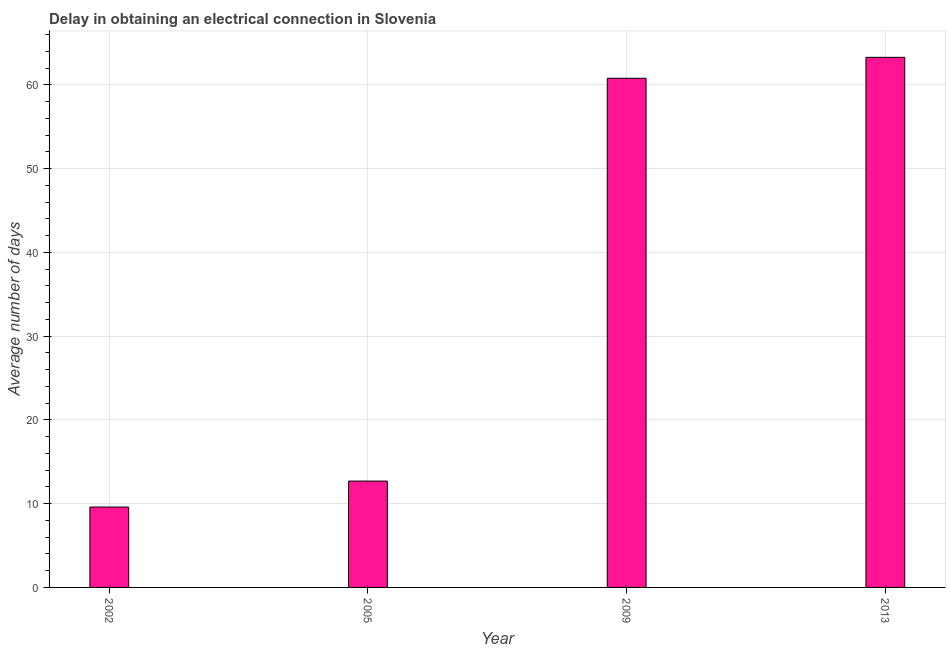What is the title of the graph?
Provide a short and direct response. Delay in obtaining an electrical connection in Slovenia. What is the label or title of the Y-axis?
Ensure brevity in your answer.  Average number of days. What is the dalay in electrical connection in 2005?
Ensure brevity in your answer.  12.7. Across all years, what is the maximum dalay in electrical connection?
Your answer should be very brief. 63.3. In which year was the dalay in electrical connection maximum?
Provide a short and direct response. 2013. In which year was the dalay in electrical connection minimum?
Ensure brevity in your answer.  2002. What is the sum of the dalay in electrical connection?
Your answer should be compact. 146.4. What is the difference between the dalay in electrical connection in 2002 and 2005?
Keep it short and to the point. -3.1. What is the average dalay in electrical connection per year?
Provide a short and direct response. 36.6. What is the median dalay in electrical connection?
Provide a short and direct response. 36.75. In how many years, is the dalay in electrical connection greater than 50 days?
Provide a succinct answer. 2. Do a majority of the years between 2009 and 2013 (inclusive) have dalay in electrical connection greater than 24 days?
Provide a succinct answer. Yes. What is the ratio of the dalay in electrical connection in 2002 to that in 2005?
Offer a very short reply. 0.76. What is the difference between the highest and the second highest dalay in electrical connection?
Ensure brevity in your answer.  2.5. What is the difference between the highest and the lowest dalay in electrical connection?
Offer a terse response. 53.7. In how many years, is the dalay in electrical connection greater than the average dalay in electrical connection taken over all years?
Make the answer very short. 2. How many bars are there?
Make the answer very short. 4. How many years are there in the graph?
Keep it short and to the point. 4. What is the difference between two consecutive major ticks on the Y-axis?
Offer a very short reply. 10. What is the Average number of days in 2005?
Offer a terse response. 12.7. What is the Average number of days in 2009?
Offer a very short reply. 60.8. What is the Average number of days of 2013?
Provide a succinct answer. 63.3. What is the difference between the Average number of days in 2002 and 2005?
Your answer should be very brief. -3.1. What is the difference between the Average number of days in 2002 and 2009?
Give a very brief answer. -51.2. What is the difference between the Average number of days in 2002 and 2013?
Provide a short and direct response. -53.7. What is the difference between the Average number of days in 2005 and 2009?
Offer a very short reply. -48.1. What is the difference between the Average number of days in 2005 and 2013?
Give a very brief answer. -50.6. What is the ratio of the Average number of days in 2002 to that in 2005?
Offer a very short reply. 0.76. What is the ratio of the Average number of days in 2002 to that in 2009?
Provide a short and direct response. 0.16. What is the ratio of the Average number of days in 2002 to that in 2013?
Your response must be concise. 0.15. What is the ratio of the Average number of days in 2005 to that in 2009?
Your answer should be very brief. 0.21. What is the ratio of the Average number of days in 2005 to that in 2013?
Offer a very short reply. 0.2. 